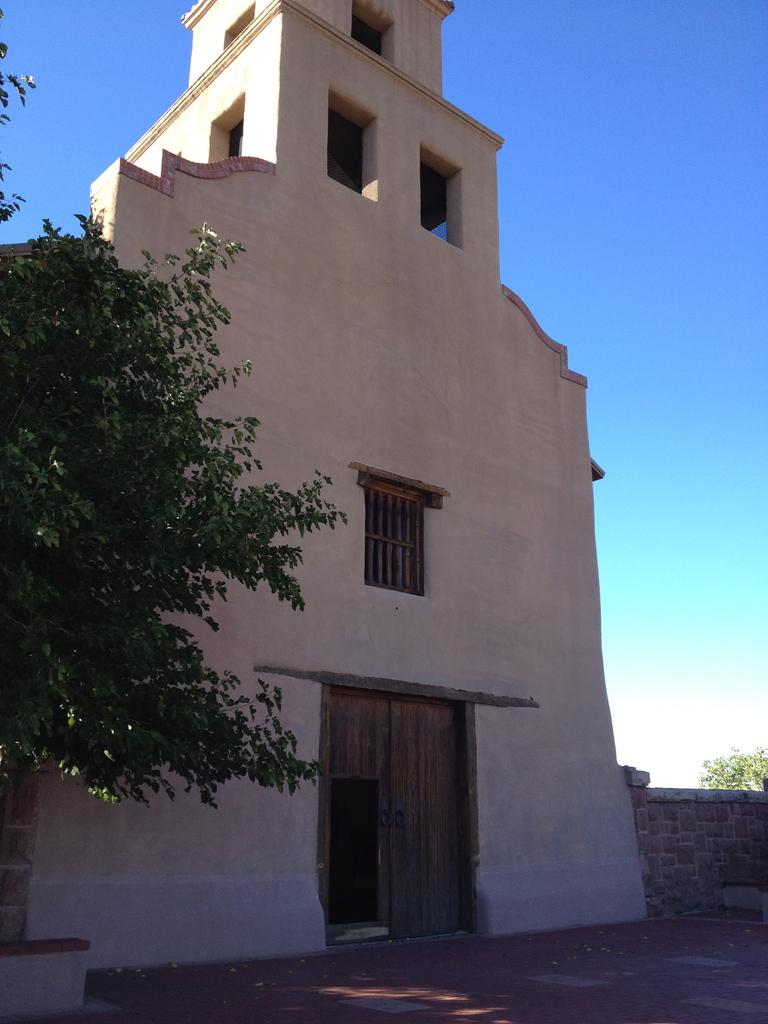What type of view is shown in the image? The image is an outside view. What structure can be seen in the image? There is a building in the image. What type of vegetation is present on both sides of the image? There are trees on the right side and on the left side of the image. What is visible at the top of the image? The sky is visible at the top of the image. Can you tell me how many flowers are in the baby's hand in the image? There is no baby or flowers present in the image; it features an outside view with a building and trees. 